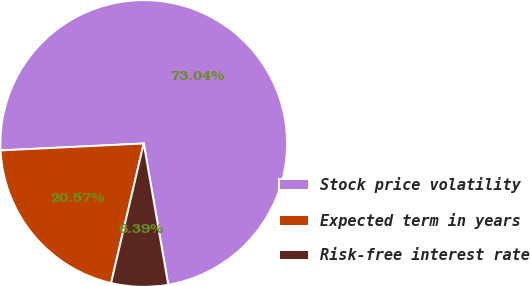Convert chart. <chart><loc_0><loc_0><loc_500><loc_500><pie_chart><fcel>Stock price volatility<fcel>Expected term in years<fcel>Risk-free interest rate<nl><fcel>73.03%<fcel>20.57%<fcel>6.39%<nl></chart> 